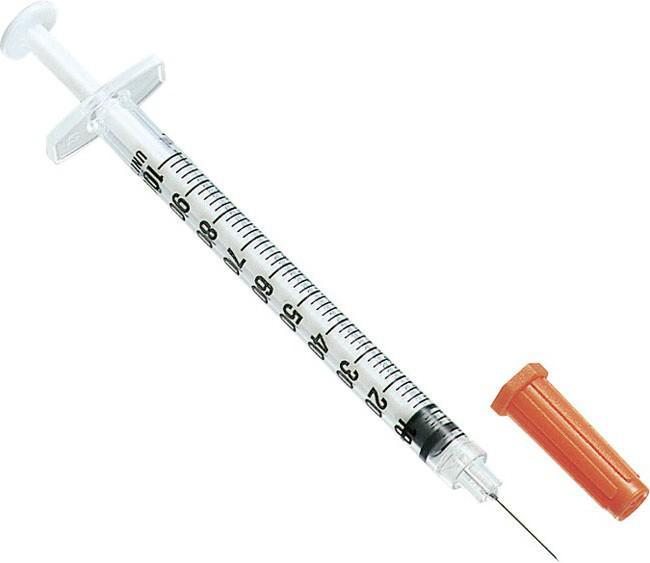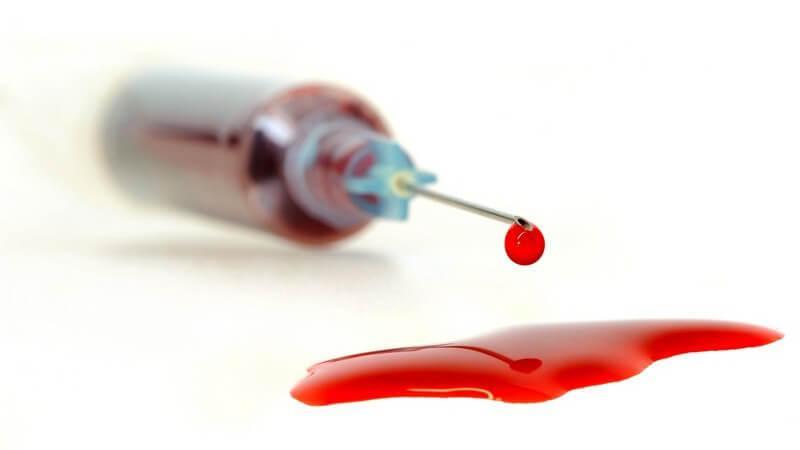The first image is the image on the left, the second image is the image on the right. For the images displayed, is the sentence "There are exactly two syringes." factually correct? Answer yes or no. Yes. The first image is the image on the left, the second image is the image on the right. For the images shown, is this caption "There are no more than 2 syringes." true? Answer yes or no. Yes. 